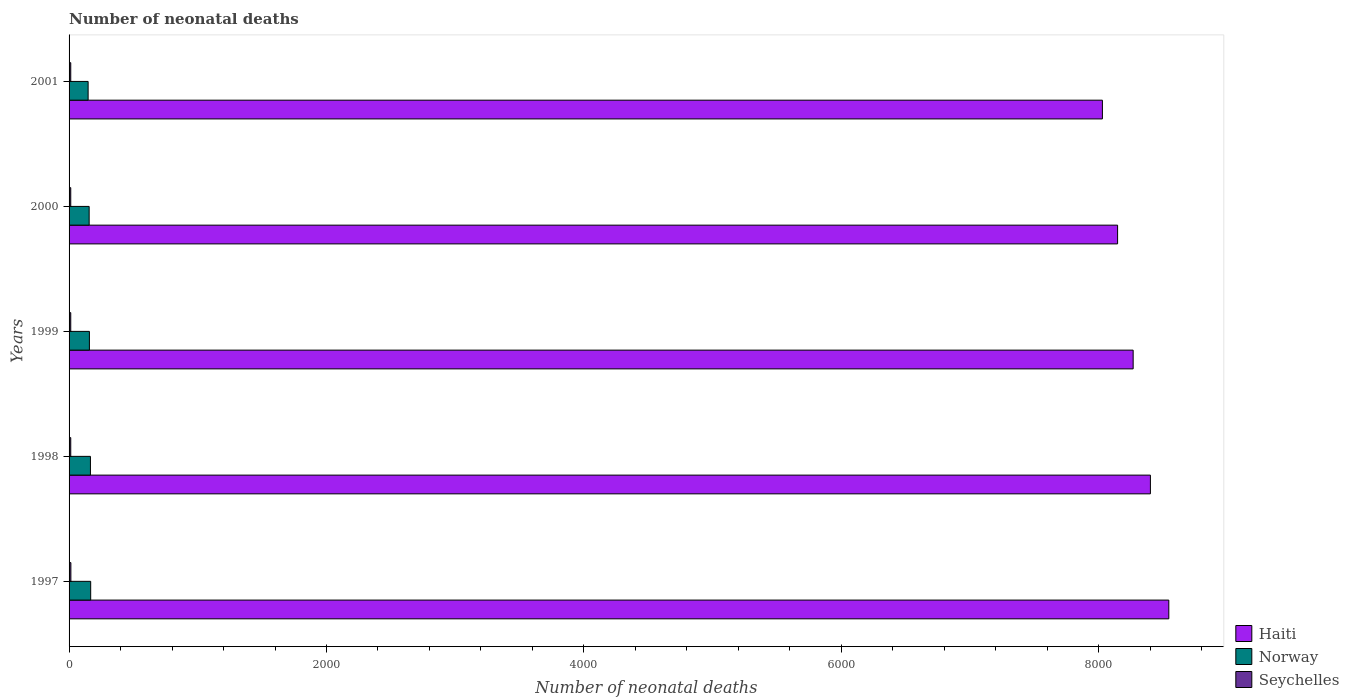How many groups of bars are there?
Keep it short and to the point. 5. How many bars are there on the 5th tick from the top?
Provide a succinct answer. 3. What is the label of the 2nd group of bars from the top?
Provide a short and direct response. 2000. What is the number of neonatal deaths in in Norway in 2000?
Offer a terse response. 156. Across all years, what is the maximum number of neonatal deaths in in Haiti?
Make the answer very short. 8544. Across all years, what is the minimum number of neonatal deaths in in Haiti?
Keep it short and to the point. 8028. What is the total number of neonatal deaths in in Norway in the graph?
Your answer should be compact. 796. What is the difference between the number of neonatal deaths in in Haiti in 1999 and that in 2000?
Your answer should be compact. 121. What is the difference between the number of neonatal deaths in in Seychelles in 2000 and the number of neonatal deaths in in Norway in 1998?
Your answer should be compact. -153. What is the average number of neonatal deaths in in Norway per year?
Ensure brevity in your answer.  159.2. In the year 1999, what is the difference between the number of neonatal deaths in in Seychelles and number of neonatal deaths in in Haiti?
Your answer should be compact. -8254. In how many years, is the number of neonatal deaths in in Norway greater than 5600 ?
Your response must be concise. 0. Is the difference between the number of neonatal deaths in in Seychelles in 1998 and 2001 greater than the difference between the number of neonatal deaths in in Haiti in 1998 and 2001?
Provide a short and direct response. No. What is the difference between the highest and the lowest number of neonatal deaths in in Haiti?
Offer a terse response. 516. Is the sum of the number of neonatal deaths in in Haiti in 1997 and 2000 greater than the maximum number of neonatal deaths in in Seychelles across all years?
Your answer should be very brief. Yes. What does the 2nd bar from the top in 1997 represents?
Make the answer very short. Norway. What does the 3rd bar from the bottom in 1999 represents?
Your answer should be very brief. Seychelles. How many bars are there?
Ensure brevity in your answer.  15. Does the graph contain grids?
Give a very brief answer. No. Where does the legend appear in the graph?
Your response must be concise. Bottom right. How many legend labels are there?
Keep it short and to the point. 3. How are the legend labels stacked?
Give a very brief answer. Vertical. What is the title of the graph?
Keep it short and to the point. Number of neonatal deaths. What is the label or title of the X-axis?
Provide a succinct answer. Number of neonatal deaths. What is the Number of neonatal deaths of Haiti in 1997?
Ensure brevity in your answer.  8544. What is the Number of neonatal deaths of Norway in 1997?
Provide a succinct answer. 168. What is the Number of neonatal deaths in Haiti in 1998?
Make the answer very short. 8401. What is the Number of neonatal deaths of Norway in 1998?
Give a very brief answer. 166. What is the Number of neonatal deaths in Haiti in 1999?
Keep it short and to the point. 8267. What is the Number of neonatal deaths in Norway in 1999?
Give a very brief answer. 158. What is the Number of neonatal deaths in Haiti in 2000?
Give a very brief answer. 8146. What is the Number of neonatal deaths of Norway in 2000?
Your answer should be compact. 156. What is the Number of neonatal deaths of Haiti in 2001?
Your response must be concise. 8028. What is the Number of neonatal deaths of Norway in 2001?
Provide a short and direct response. 148. What is the Number of neonatal deaths in Seychelles in 2001?
Give a very brief answer. 13. Across all years, what is the maximum Number of neonatal deaths in Haiti?
Keep it short and to the point. 8544. Across all years, what is the maximum Number of neonatal deaths in Norway?
Your response must be concise. 168. Across all years, what is the minimum Number of neonatal deaths in Haiti?
Keep it short and to the point. 8028. Across all years, what is the minimum Number of neonatal deaths in Norway?
Provide a succinct answer. 148. What is the total Number of neonatal deaths of Haiti in the graph?
Make the answer very short. 4.14e+04. What is the total Number of neonatal deaths in Norway in the graph?
Ensure brevity in your answer.  796. What is the difference between the Number of neonatal deaths in Haiti in 1997 and that in 1998?
Your answer should be very brief. 143. What is the difference between the Number of neonatal deaths of Haiti in 1997 and that in 1999?
Your answer should be very brief. 277. What is the difference between the Number of neonatal deaths of Haiti in 1997 and that in 2000?
Keep it short and to the point. 398. What is the difference between the Number of neonatal deaths of Norway in 1997 and that in 2000?
Provide a succinct answer. 12. What is the difference between the Number of neonatal deaths of Haiti in 1997 and that in 2001?
Your answer should be very brief. 516. What is the difference between the Number of neonatal deaths of Norway in 1997 and that in 2001?
Offer a terse response. 20. What is the difference between the Number of neonatal deaths of Haiti in 1998 and that in 1999?
Ensure brevity in your answer.  134. What is the difference between the Number of neonatal deaths of Seychelles in 1998 and that in 1999?
Keep it short and to the point. 0. What is the difference between the Number of neonatal deaths in Haiti in 1998 and that in 2000?
Your response must be concise. 255. What is the difference between the Number of neonatal deaths in Norway in 1998 and that in 2000?
Ensure brevity in your answer.  10. What is the difference between the Number of neonatal deaths in Haiti in 1998 and that in 2001?
Ensure brevity in your answer.  373. What is the difference between the Number of neonatal deaths in Seychelles in 1998 and that in 2001?
Make the answer very short. 0. What is the difference between the Number of neonatal deaths in Haiti in 1999 and that in 2000?
Ensure brevity in your answer.  121. What is the difference between the Number of neonatal deaths in Norway in 1999 and that in 2000?
Your answer should be very brief. 2. What is the difference between the Number of neonatal deaths in Haiti in 1999 and that in 2001?
Offer a very short reply. 239. What is the difference between the Number of neonatal deaths in Norway in 1999 and that in 2001?
Keep it short and to the point. 10. What is the difference between the Number of neonatal deaths of Haiti in 2000 and that in 2001?
Give a very brief answer. 118. What is the difference between the Number of neonatal deaths of Haiti in 1997 and the Number of neonatal deaths of Norway in 1998?
Provide a short and direct response. 8378. What is the difference between the Number of neonatal deaths in Haiti in 1997 and the Number of neonatal deaths in Seychelles in 1998?
Provide a succinct answer. 8531. What is the difference between the Number of neonatal deaths of Norway in 1997 and the Number of neonatal deaths of Seychelles in 1998?
Your response must be concise. 155. What is the difference between the Number of neonatal deaths of Haiti in 1997 and the Number of neonatal deaths of Norway in 1999?
Offer a very short reply. 8386. What is the difference between the Number of neonatal deaths in Haiti in 1997 and the Number of neonatal deaths in Seychelles in 1999?
Make the answer very short. 8531. What is the difference between the Number of neonatal deaths in Norway in 1997 and the Number of neonatal deaths in Seychelles in 1999?
Ensure brevity in your answer.  155. What is the difference between the Number of neonatal deaths of Haiti in 1997 and the Number of neonatal deaths of Norway in 2000?
Your response must be concise. 8388. What is the difference between the Number of neonatal deaths of Haiti in 1997 and the Number of neonatal deaths of Seychelles in 2000?
Ensure brevity in your answer.  8531. What is the difference between the Number of neonatal deaths in Norway in 1997 and the Number of neonatal deaths in Seychelles in 2000?
Keep it short and to the point. 155. What is the difference between the Number of neonatal deaths in Haiti in 1997 and the Number of neonatal deaths in Norway in 2001?
Your response must be concise. 8396. What is the difference between the Number of neonatal deaths in Haiti in 1997 and the Number of neonatal deaths in Seychelles in 2001?
Give a very brief answer. 8531. What is the difference between the Number of neonatal deaths of Norway in 1997 and the Number of neonatal deaths of Seychelles in 2001?
Give a very brief answer. 155. What is the difference between the Number of neonatal deaths in Haiti in 1998 and the Number of neonatal deaths in Norway in 1999?
Offer a terse response. 8243. What is the difference between the Number of neonatal deaths in Haiti in 1998 and the Number of neonatal deaths in Seychelles in 1999?
Give a very brief answer. 8388. What is the difference between the Number of neonatal deaths of Norway in 1998 and the Number of neonatal deaths of Seychelles in 1999?
Your response must be concise. 153. What is the difference between the Number of neonatal deaths of Haiti in 1998 and the Number of neonatal deaths of Norway in 2000?
Ensure brevity in your answer.  8245. What is the difference between the Number of neonatal deaths in Haiti in 1998 and the Number of neonatal deaths in Seychelles in 2000?
Keep it short and to the point. 8388. What is the difference between the Number of neonatal deaths of Norway in 1998 and the Number of neonatal deaths of Seychelles in 2000?
Keep it short and to the point. 153. What is the difference between the Number of neonatal deaths in Haiti in 1998 and the Number of neonatal deaths in Norway in 2001?
Your answer should be compact. 8253. What is the difference between the Number of neonatal deaths of Haiti in 1998 and the Number of neonatal deaths of Seychelles in 2001?
Provide a short and direct response. 8388. What is the difference between the Number of neonatal deaths in Norway in 1998 and the Number of neonatal deaths in Seychelles in 2001?
Your answer should be compact. 153. What is the difference between the Number of neonatal deaths in Haiti in 1999 and the Number of neonatal deaths in Norway in 2000?
Keep it short and to the point. 8111. What is the difference between the Number of neonatal deaths in Haiti in 1999 and the Number of neonatal deaths in Seychelles in 2000?
Ensure brevity in your answer.  8254. What is the difference between the Number of neonatal deaths in Norway in 1999 and the Number of neonatal deaths in Seychelles in 2000?
Your answer should be compact. 145. What is the difference between the Number of neonatal deaths in Haiti in 1999 and the Number of neonatal deaths in Norway in 2001?
Give a very brief answer. 8119. What is the difference between the Number of neonatal deaths of Haiti in 1999 and the Number of neonatal deaths of Seychelles in 2001?
Provide a succinct answer. 8254. What is the difference between the Number of neonatal deaths of Norway in 1999 and the Number of neonatal deaths of Seychelles in 2001?
Your answer should be compact. 145. What is the difference between the Number of neonatal deaths in Haiti in 2000 and the Number of neonatal deaths in Norway in 2001?
Offer a terse response. 7998. What is the difference between the Number of neonatal deaths of Haiti in 2000 and the Number of neonatal deaths of Seychelles in 2001?
Make the answer very short. 8133. What is the difference between the Number of neonatal deaths of Norway in 2000 and the Number of neonatal deaths of Seychelles in 2001?
Keep it short and to the point. 143. What is the average Number of neonatal deaths of Haiti per year?
Provide a short and direct response. 8277.2. What is the average Number of neonatal deaths in Norway per year?
Offer a terse response. 159.2. What is the average Number of neonatal deaths of Seychelles per year?
Provide a short and direct response. 13.2. In the year 1997, what is the difference between the Number of neonatal deaths of Haiti and Number of neonatal deaths of Norway?
Your response must be concise. 8376. In the year 1997, what is the difference between the Number of neonatal deaths of Haiti and Number of neonatal deaths of Seychelles?
Keep it short and to the point. 8530. In the year 1997, what is the difference between the Number of neonatal deaths in Norway and Number of neonatal deaths in Seychelles?
Provide a succinct answer. 154. In the year 1998, what is the difference between the Number of neonatal deaths of Haiti and Number of neonatal deaths of Norway?
Your response must be concise. 8235. In the year 1998, what is the difference between the Number of neonatal deaths in Haiti and Number of neonatal deaths in Seychelles?
Ensure brevity in your answer.  8388. In the year 1998, what is the difference between the Number of neonatal deaths in Norway and Number of neonatal deaths in Seychelles?
Provide a succinct answer. 153. In the year 1999, what is the difference between the Number of neonatal deaths of Haiti and Number of neonatal deaths of Norway?
Your response must be concise. 8109. In the year 1999, what is the difference between the Number of neonatal deaths of Haiti and Number of neonatal deaths of Seychelles?
Ensure brevity in your answer.  8254. In the year 1999, what is the difference between the Number of neonatal deaths of Norway and Number of neonatal deaths of Seychelles?
Your answer should be very brief. 145. In the year 2000, what is the difference between the Number of neonatal deaths in Haiti and Number of neonatal deaths in Norway?
Offer a terse response. 7990. In the year 2000, what is the difference between the Number of neonatal deaths of Haiti and Number of neonatal deaths of Seychelles?
Keep it short and to the point. 8133. In the year 2000, what is the difference between the Number of neonatal deaths in Norway and Number of neonatal deaths in Seychelles?
Your answer should be very brief. 143. In the year 2001, what is the difference between the Number of neonatal deaths of Haiti and Number of neonatal deaths of Norway?
Ensure brevity in your answer.  7880. In the year 2001, what is the difference between the Number of neonatal deaths in Haiti and Number of neonatal deaths in Seychelles?
Ensure brevity in your answer.  8015. In the year 2001, what is the difference between the Number of neonatal deaths in Norway and Number of neonatal deaths in Seychelles?
Provide a short and direct response. 135. What is the ratio of the Number of neonatal deaths of Haiti in 1997 to that in 1998?
Provide a short and direct response. 1.02. What is the ratio of the Number of neonatal deaths of Haiti in 1997 to that in 1999?
Keep it short and to the point. 1.03. What is the ratio of the Number of neonatal deaths in Norway in 1997 to that in 1999?
Give a very brief answer. 1.06. What is the ratio of the Number of neonatal deaths of Seychelles in 1997 to that in 1999?
Provide a succinct answer. 1.08. What is the ratio of the Number of neonatal deaths in Haiti in 1997 to that in 2000?
Ensure brevity in your answer.  1.05. What is the ratio of the Number of neonatal deaths in Seychelles in 1997 to that in 2000?
Offer a terse response. 1.08. What is the ratio of the Number of neonatal deaths of Haiti in 1997 to that in 2001?
Keep it short and to the point. 1.06. What is the ratio of the Number of neonatal deaths of Norway in 1997 to that in 2001?
Provide a succinct answer. 1.14. What is the ratio of the Number of neonatal deaths of Seychelles in 1997 to that in 2001?
Ensure brevity in your answer.  1.08. What is the ratio of the Number of neonatal deaths in Haiti in 1998 to that in 1999?
Your answer should be compact. 1.02. What is the ratio of the Number of neonatal deaths of Norway in 1998 to that in 1999?
Give a very brief answer. 1.05. What is the ratio of the Number of neonatal deaths in Haiti in 1998 to that in 2000?
Offer a terse response. 1.03. What is the ratio of the Number of neonatal deaths in Norway in 1998 to that in 2000?
Your answer should be compact. 1.06. What is the ratio of the Number of neonatal deaths in Seychelles in 1998 to that in 2000?
Ensure brevity in your answer.  1. What is the ratio of the Number of neonatal deaths in Haiti in 1998 to that in 2001?
Offer a terse response. 1.05. What is the ratio of the Number of neonatal deaths of Norway in 1998 to that in 2001?
Provide a short and direct response. 1.12. What is the ratio of the Number of neonatal deaths of Haiti in 1999 to that in 2000?
Offer a terse response. 1.01. What is the ratio of the Number of neonatal deaths in Norway in 1999 to that in 2000?
Offer a terse response. 1.01. What is the ratio of the Number of neonatal deaths of Haiti in 1999 to that in 2001?
Provide a short and direct response. 1.03. What is the ratio of the Number of neonatal deaths in Norway in 1999 to that in 2001?
Offer a terse response. 1.07. What is the ratio of the Number of neonatal deaths of Seychelles in 1999 to that in 2001?
Ensure brevity in your answer.  1. What is the ratio of the Number of neonatal deaths in Haiti in 2000 to that in 2001?
Give a very brief answer. 1.01. What is the ratio of the Number of neonatal deaths in Norway in 2000 to that in 2001?
Your answer should be compact. 1.05. What is the difference between the highest and the second highest Number of neonatal deaths of Haiti?
Your answer should be compact. 143. What is the difference between the highest and the lowest Number of neonatal deaths of Haiti?
Your answer should be very brief. 516. What is the difference between the highest and the lowest Number of neonatal deaths in Norway?
Provide a short and direct response. 20. What is the difference between the highest and the lowest Number of neonatal deaths in Seychelles?
Your answer should be compact. 1. 